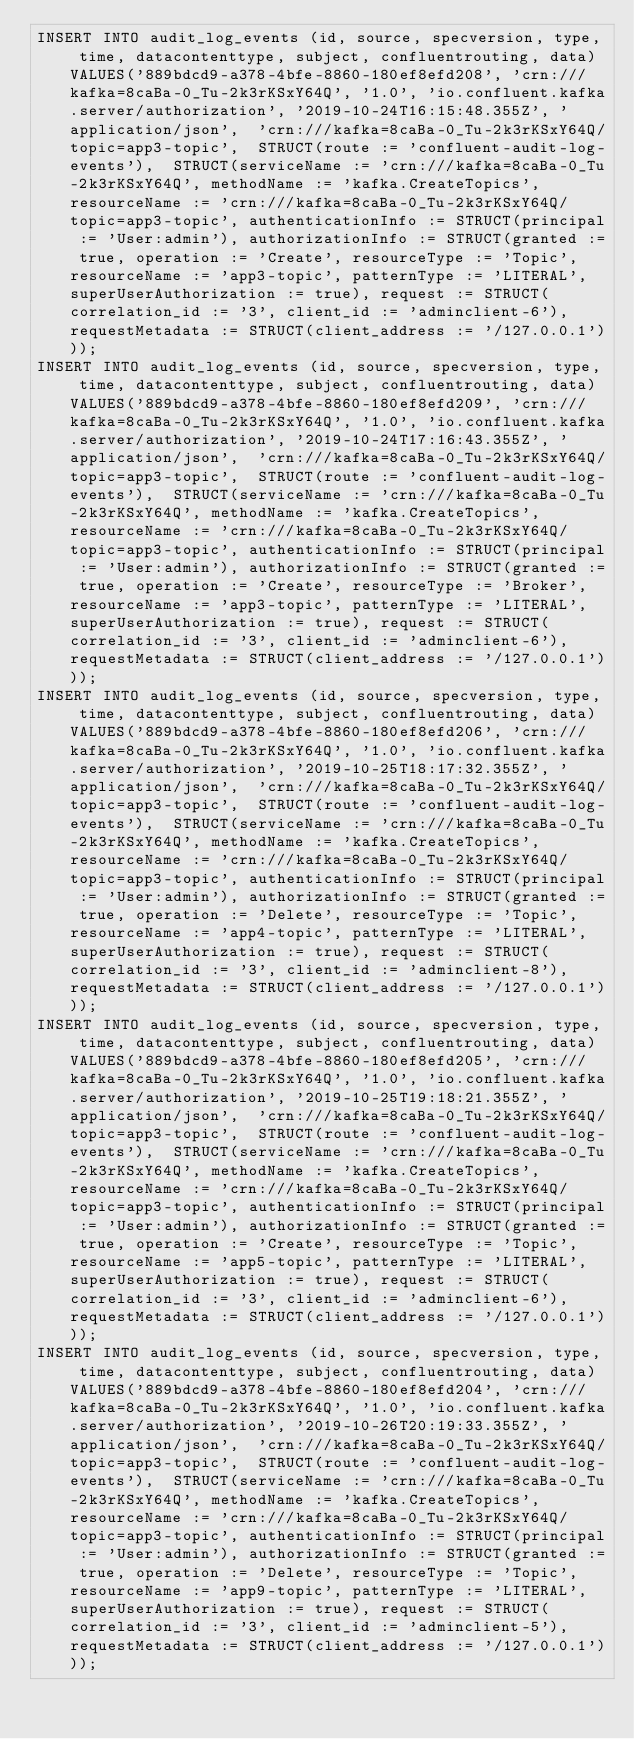Convert code to text. <code><loc_0><loc_0><loc_500><loc_500><_SQL_>INSERT INTO audit_log_events (id, source, specversion, type, time, datacontenttype, subject, confluentrouting, data) VALUES('889bdcd9-a378-4bfe-8860-180ef8efd208', 'crn:///kafka=8caBa-0_Tu-2k3rKSxY64Q', '1.0', 'io.confluent.kafka.server/authorization', '2019-10-24T16:15:48.355Z', 'application/json',  'crn:///kafka=8caBa-0_Tu-2k3rKSxY64Q/topic=app3-topic',  STRUCT(route := 'confluent-audit-log-events'),  STRUCT(serviceName := 'crn:///kafka=8caBa-0_Tu-2k3rKSxY64Q', methodName := 'kafka.CreateTopics', resourceName := 'crn:///kafka=8caBa-0_Tu-2k3rKSxY64Q/topic=app3-topic', authenticationInfo := STRUCT(principal := 'User:admin'), authorizationInfo := STRUCT(granted := true, operation := 'Create', resourceType := 'Topic', resourceName := 'app3-topic', patternType := 'LITERAL', superUserAuthorization := true), request := STRUCT(correlation_id := '3', client_id := 'adminclient-6'), requestMetadata := STRUCT(client_address := '/127.0.0.1')));	
INSERT INTO audit_log_events (id, source, specversion, type, time, datacontenttype, subject, confluentrouting, data) VALUES('889bdcd9-a378-4bfe-8860-180ef8efd209', 'crn:///kafka=8caBa-0_Tu-2k3rKSxY64Q', '1.0', 'io.confluent.kafka.server/authorization', '2019-10-24T17:16:43.355Z', 'application/json',  'crn:///kafka=8caBa-0_Tu-2k3rKSxY64Q/topic=app3-topic',  STRUCT(route := 'confluent-audit-log-events'),  STRUCT(serviceName := 'crn:///kafka=8caBa-0_Tu-2k3rKSxY64Q', methodName := 'kafka.CreateTopics', resourceName := 'crn:///kafka=8caBa-0_Tu-2k3rKSxY64Q/topic=app3-topic', authenticationInfo := STRUCT(principal := 'User:admin'), authorizationInfo := STRUCT(granted := true, operation := 'Create', resourceType := 'Broker', resourceName := 'app3-topic', patternType := 'LITERAL', superUserAuthorization := true), request := STRUCT(correlation_id := '3', client_id := 'adminclient-6'), requestMetadata := STRUCT(client_address := '/127.0.0.1')));
INSERT INTO audit_log_events (id, source, specversion, type, time, datacontenttype, subject, confluentrouting, data) VALUES('889bdcd9-a378-4bfe-8860-180ef8efd206', 'crn:///kafka=8caBa-0_Tu-2k3rKSxY64Q', '1.0', 'io.confluent.kafka.server/authorization', '2019-10-25T18:17:32.355Z', 'application/json',  'crn:///kafka=8caBa-0_Tu-2k3rKSxY64Q/topic=app3-topic',  STRUCT(route := 'confluent-audit-log-events'),  STRUCT(serviceName := 'crn:///kafka=8caBa-0_Tu-2k3rKSxY64Q', methodName := 'kafka.CreateTopics', resourceName := 'crn:///kafka=8caBa-0_Tu-2k3rKSxY64Q/topic=app3-topic', authenticationInfo := STRUCT(principal := 'User:admin'), authorizationInfo := STRUCT(granted := true, operation := 'Delete', resourceType := 'Topic', resourceName := 'app4-topic', patternType := 'LITERAL', superUserAuthorization := true), request := STRUCT(correlation_id := '3', client_id := 'adminclient-8'), requestMetadata := STRUCT(client_address := '/127.0.0.1')));
INSERT INTO audit_log_events (id, source, specversion, type, time, datacontenttype, subject, confluentrouting, data) VALUES('889bdcd9-a378-4bfe-8860-180ef8efd205', 'crn:///kafka=8caBa-0_Tu-2k3rKSxY64Q', '1.0', 'io.confluent.kafka.server/authorization', '2019-10-25T19:18:21.355Z', 'application/json',  'crn:///kafka=8caBa-0_Tu-2k3rKSxY64Q/topic=app3-topic',  STRUCT(route := 'confluent-audit-log-events'),  STRUCT(serviceName := 'crn:///kafka=8caBa-0_Tu-2k3rKSxY64Q', methodName := 'kafka.CreateTopics', resourceName := 'crn:///kafka=8caBa-0_Tu-2k3rKSxY64Q/topic=app3-topic', authenticationInfo := STRUCT(principal := 'User:admin'), authorizationInfo := STRUCT(granted := true, operation := 'Create', resourceType := 'Topic', resourceName := 'app5-topic', patternType := 'LITERAL', superUserAuthorization := true), request := STRUCT(correlation_id := '3', client_id := 'adminclient-6'), requestMetadata := STRUCT(client_address := '/127.0.0.1')));
INSERT INTO audit_log_events (id, source, specversion, type, time, datacontenttype, subject, confluentrouting, data) VALUES('889bdcd9-a378-4bfe-8860-180ef8efd204', 'crn:///kafka=8caBa-0_Tu-2k3rKSxY64Q', '1.0', 'io.confluent.kafka.server/authorization', '2019-10-26T20:19:33.355Z', 'application/json',  'crn:///kafka=8caBa-0_Tu-2k3rKSxY64Q/topic=app3-topic',  STRUCT(route := 'confluent-audit-log-events'),  STRUCT(serviceName := 'crn:///kafka=8caBa-0_Tu-2k3rKSxY64Q', methodName := 'kafka.CreateTopics', resourceName := 'crn:///kafka=8caBa-0_Tu-2k3rKSxY64Q/topic=app3-topic', authenticationInfo := STRUCT(principal := 'User:admin'), authorizationInfo := STRUCT(granted := true, operation := 'Delete', resourceType := 'Topic', resourceName := 'app9-topic', patternType := 'LITERAL', superUserAuthorization := true), request := STRUCT(correlation_id := '3', client_id := 'adminclient-5'), requestMetadata := STRUCT(client_address := '/127.0.0.1')));</code> 